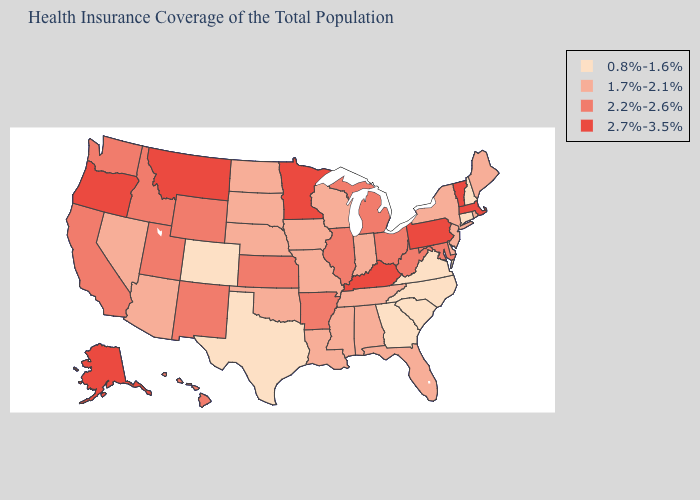Does Tennessee have the same value as Missouri?
Write a very short answer. Yes. What is the value of New Hampshire?
Give a very brief answer. 0.8%-1.6%. Does the map have missing data?
Be succinct. No. Name the states that have a value in the range 2.2%-2.6%?
Give a very brief answer. Arkansas, California, Hawaii, Idaho, Illinois, Kansas, Maryland, Michigan, New Mexico, Ohio, Utah, Washington, West Virginia, Wyoming. What is the highest value in the USA?
Short answer required. 2.7%-3.5%. Does the first symbol in the legend represent the smallest category?
Concise answer only. Yes. Is the legend a continuous bar?
Write a very short answer. No. What is the highest value in the Northeast ?
Answer briefly. 2.7%-3.5%. Does Florida have the lowest value in the South?
Be succinct. No. Which states have the highest value in the USA?
Write a very short answer. Alaska, Kentucky, Massachusetts, Minnesota, Montana, Oregon, Pennsylvania, Vermont. Among the states that border Maine , which have the highest value?
Write a very short answer. New Hampshire. What is the value of Ohio?
Write a very short answer. 2.2%-2.6%. Among the states that border South Dakota , does Minnesota have the highest value?
Concise answer only. Yes. Name the states that have a value in the range 1.7%-2.1%?
Answer briefly. Alabama, Arizona, Delaware, Florida, Indiana, Iowa, Louisiana, Maine, Mississippi, Missouri, Nebraska, Nevada, New Jersey, New York, North Dakota, Oklahoma, Rhode Island, South Dakota, Tennessee, Wisconsin. Name the states that have a value in the range 0.8%-1.6%?
Be succinct. Colorado, Connecticut, Georgia, New Hampshire, North Carolina, South Carolina, Texas, Virginia. 